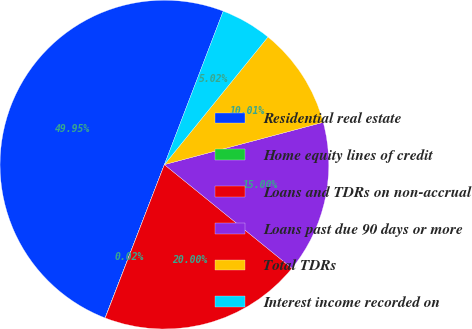Convert chart to OTSL. <chart><loc_0><loc_0><loc_500><loc_500><pie_chart><fcel>Residential real estate<fcel>Home equity lines of credit<fcel>Loans and TDRs on non-accrual<fcel>Loans past due 90 days or more<fcel>Total TDRs<fcel>Interest income recorded on<nl><fcel>49.95%<fcel>0.02%<fcel>20.0%<fcel>15.0%<fcel>10.01%<fcel>5.02%<nl></chart> 